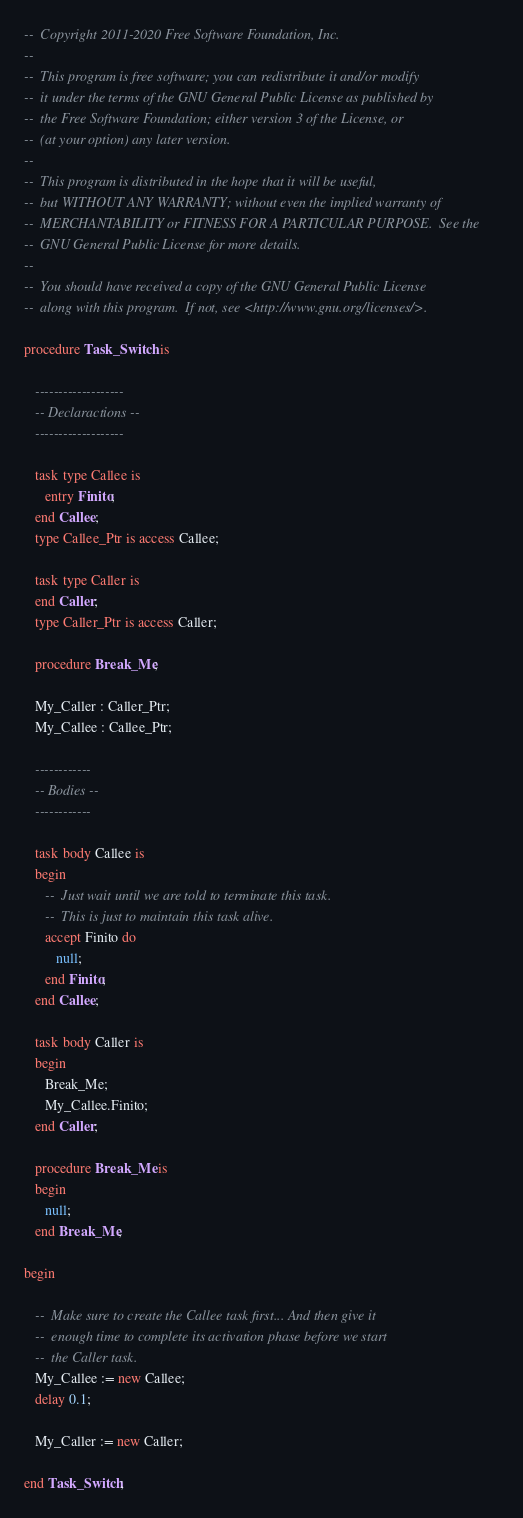Convert code to text. <code><loc_0><loc_0><loc_500><loc_500><_Ada_>--  Copyright 2011-2020 Free Software Foundation, Inc.
--
--  This program is free software; you can redistribute it and/or modify
--  it under the terms of the GNU General Public License as published by
--  the Free Software Foundation; either version 3 of the License, or
--  (at your option) any later version.
--
--  This program is distributed in the hope that it will be useful,
--  but WITHOUT ANY WARRANTY; without even the implied warranty of
--  MERCHANTABILITY or FITNESS FOR A PARTICULAR PURPOSE.  See the
--  GNU General Public License for more details.
--
--  You should have received a copy of the GNU General Public License
--  along with this program.  If not, see <http://www.gnu.org/licenses/>.

procedure Task_Switch is

   -------------------
   -- Declaractions --
   -------------------

   task type Callee is
      entry Finito;
   end Callee;
   type Callee_Ptr is access Callee;

   task type Caller is
   end Caller;
   type Caller_Ptr is access Caller;

   procedure Break_Me;

   My_Caller : Caller_Ptr;
   My_Callee : Callee_Ptr;

   ------------
   -- Bodies --
   ------------

   task body Callee is
   begin
      --  Just wait until we are told to terminate this task.
      --  This is just to maintain this task alive.
      accept Finito do
         null;
      end Finito;
   end Callee;

   task body Caller is
   begin
      Break_Me;
      My_Callee.Finito;
   end Caller;

   procedure Break_Me is
   begin
      null;
   end Break_Me;

begin

   --  Make sure to create the Callee task first... And then give it
   --  enough time to complete its activation phase before we start
   --  the Caller task.
   My_Callee := new Callee;
   delay 0.1;

   My_Caller := new Caller;

end Task_Switch;
</code> 